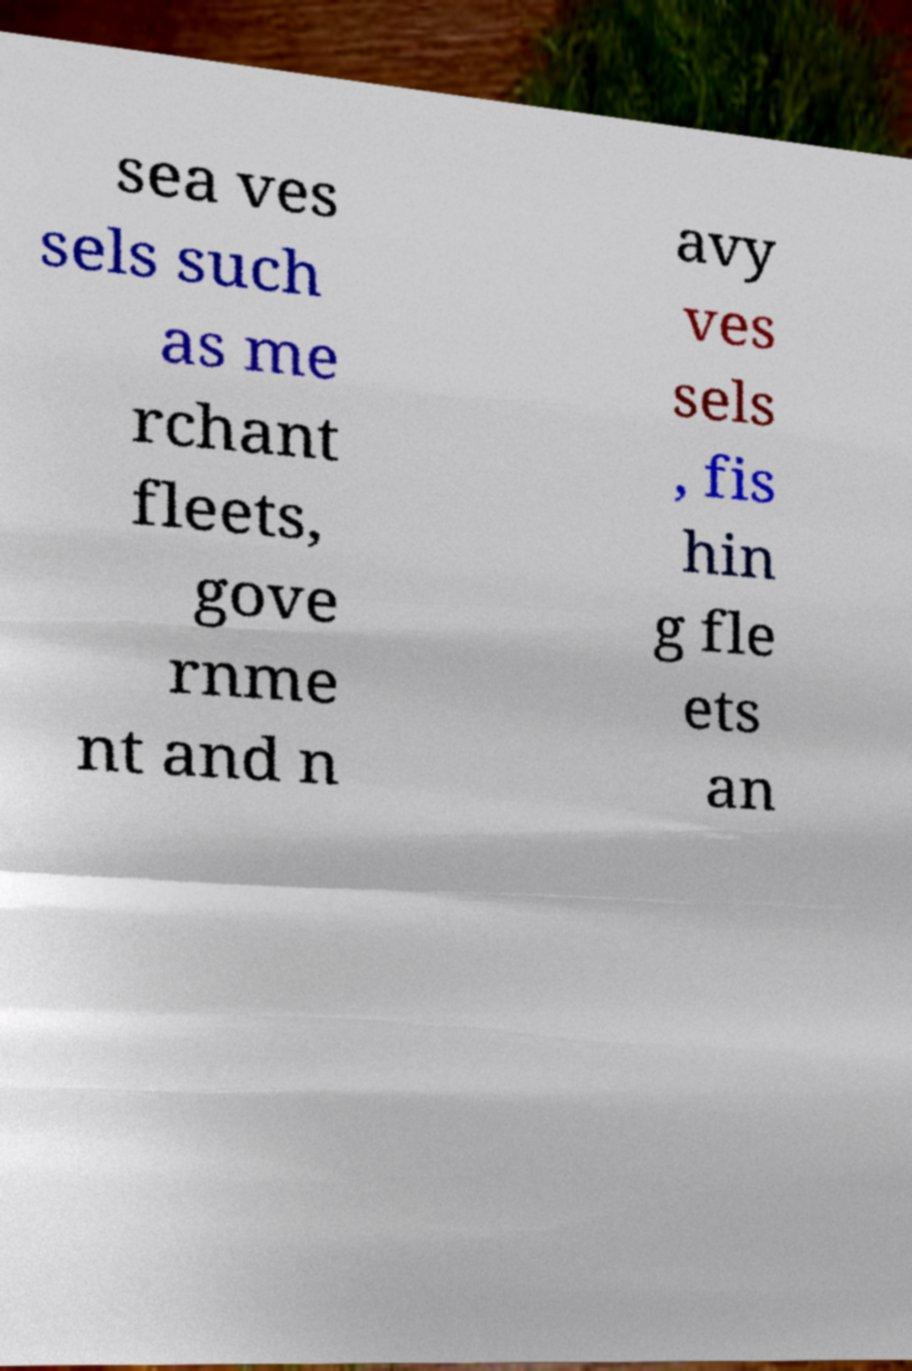What messages or text are displayed in this image? I need them in a readable, typed format. sea ves sels such as me rchant fleets, gove rnme nt and n avy ves sels , fis hin g fle ets an 